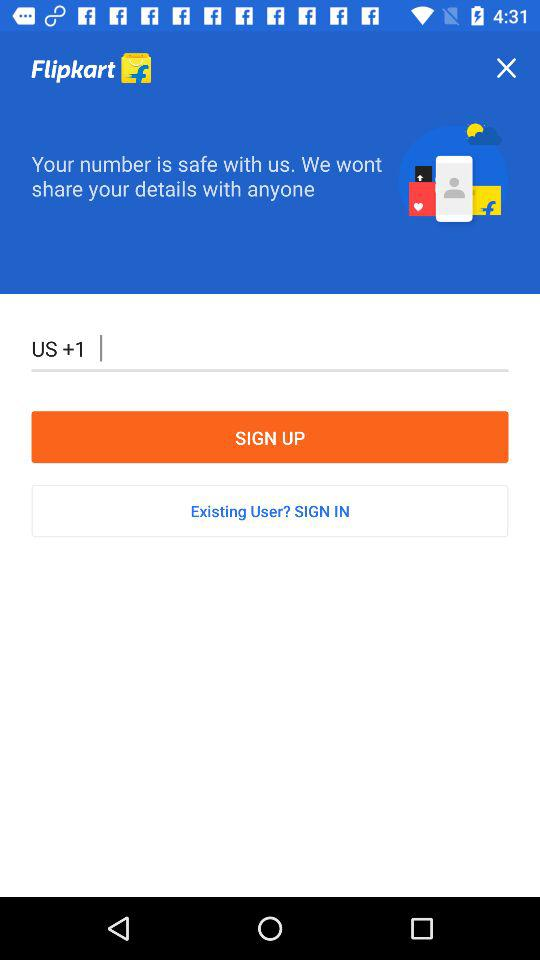What is the name of the application? The name of the application is "Flipkart". 